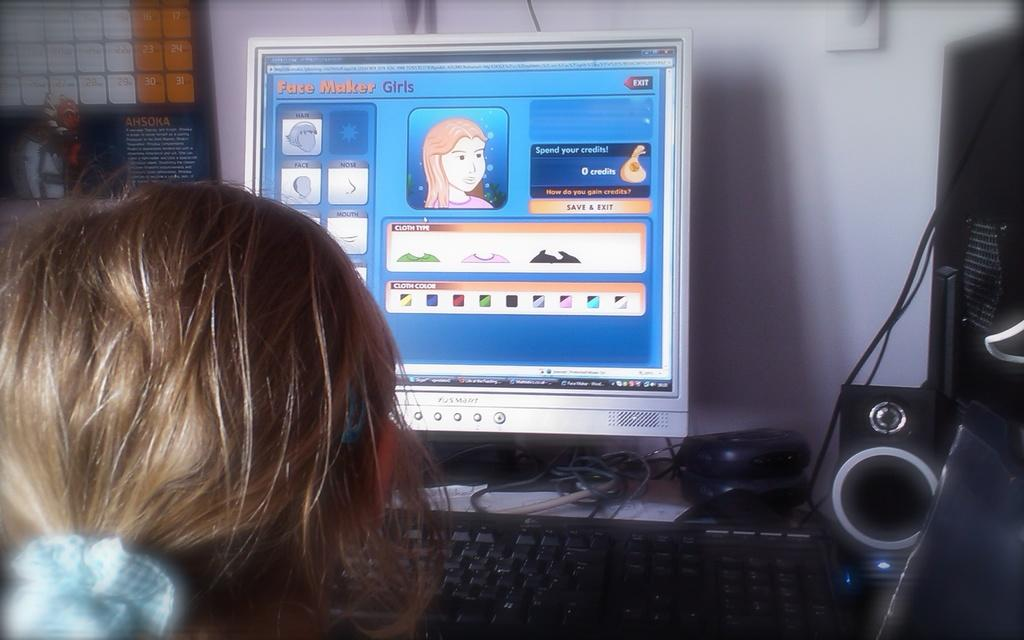What is the person in the image doing? The person is sitting at the computer in the image. What device is used for input on the computer? There is a mouse and a keyboard on the table. What is used for audio output on the computer? There is a speaker on the table. What is the main component of the computer system? There is a CPU on the table. What can be seen in the background of the image? There is a wall and a calendar in the background of the image. What type of sheet is being used by the person to skate on the computer? There is no sheet or skating activity present in the image; the person is simply sitting at the computer. 